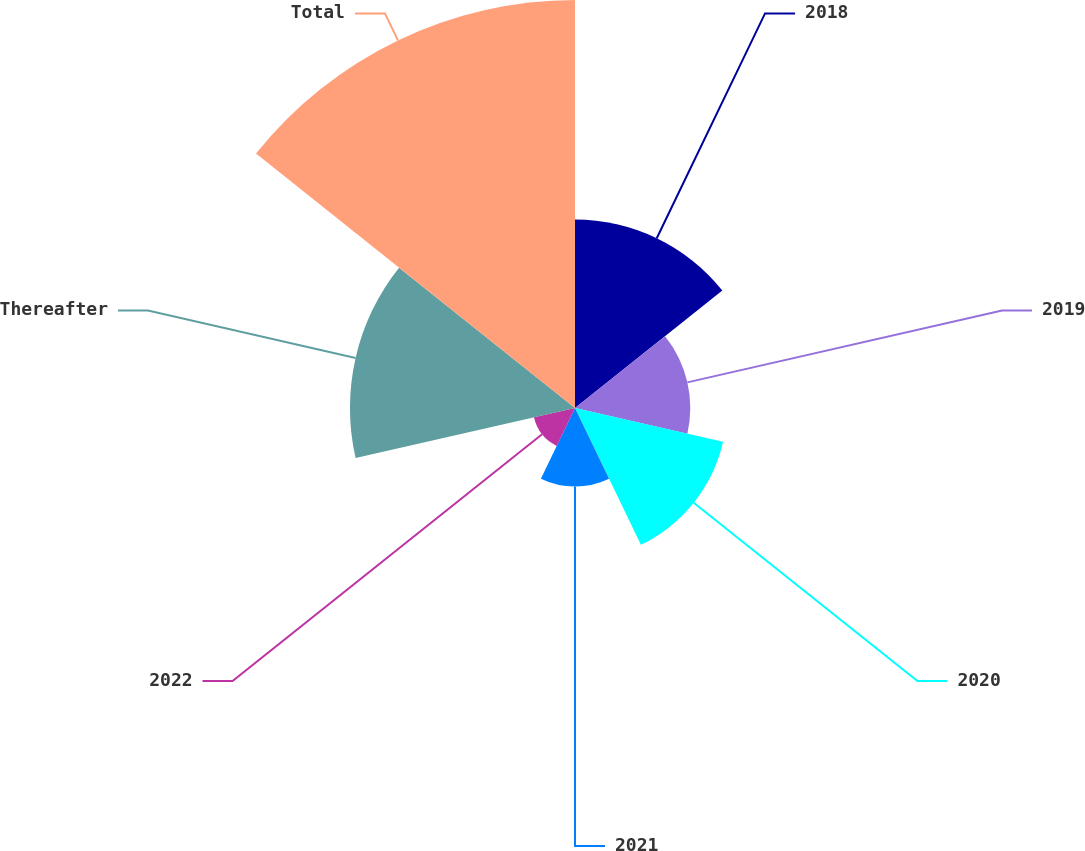Convert chart. <chart><loc_0><loc_0><loc_500><loc_500><pie_chart><fcel>2018<fcel>2019<fcel>2020<fcel>2021<fcel>2022<fcel>Thereafter<fcel>Total<nl><fcel>15.58%<fcel>9.53%<fcel>12.56%<fcel>6.5%<fcel>3.48%<fcel>18.61%<fcel>33.74%<nl></chart> 